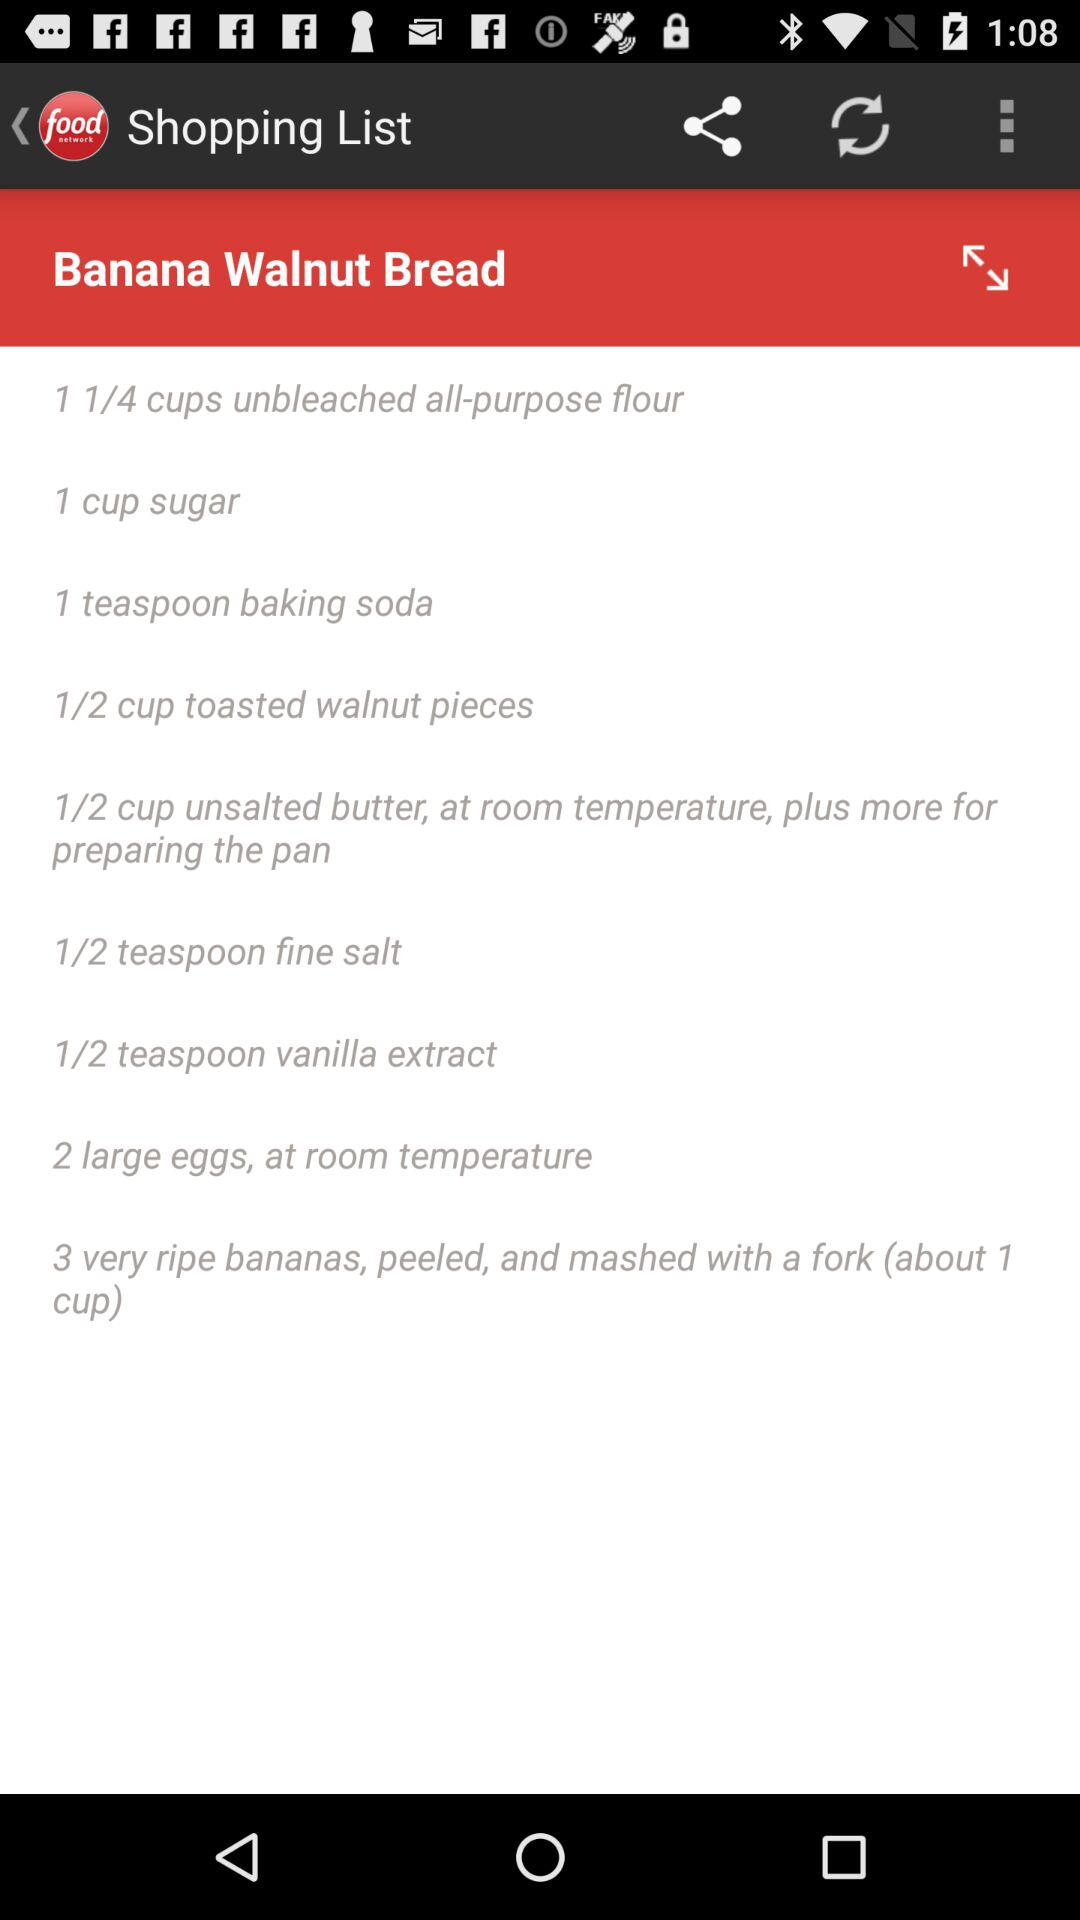How many calories does "Banana Walnut Bread" have?
When the provided information is insufficient, respond with <no answer>. <no answer> 